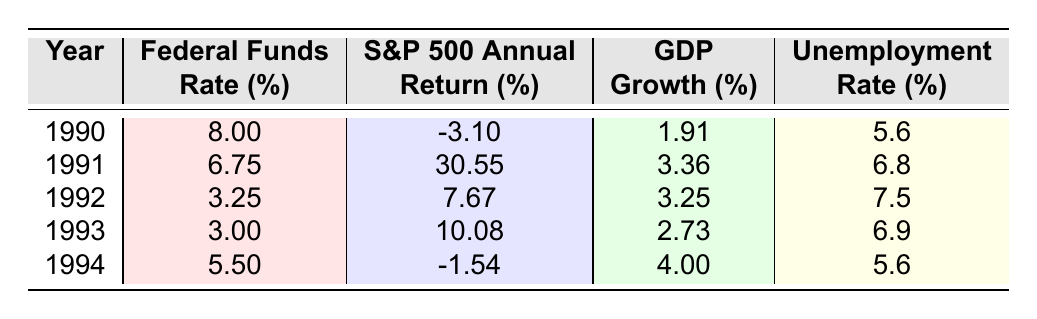What was the Federal Funds Rate in 1992? The table lists the Federal Funds Rate for each year. For 1992, the column shows a rate of 3.25%.
Answer: 3.25% What was the S&P 500 Annual Return in 1990? By checking the S&P 500 Annual Return column for the year 1990, it shows a return of -3.10%.
Answer: -3.10% What is the GDP Growth for 1994? The GDP Growth column indicates that the growth rate for 1994 is 4.00%.
Answer: 4.00% In which year did the S&P 500 Annual Return peak? The S&P 500 Annual Return shows the highest value of 30.55% in 1991.
Answer: 1991 What was the trend in Federal Funds Rates from 1990 to 1994? By comparing the values in the Federal Funds Rate column, it shows a decrease from 8.00% in 1990 to 3.00% in 1993, then an increase to 5.50% in 1994. Thus, it first decreases and then increases.
Answer: Decreases then increases Calculate the average Federal Funds Rate for the years 1990 to 1994. Adding the rates: 8.00 + 6.75 + 3.25 + 3.00 + 5.50 = 26.50. Then, divide by 5 to find the average: 26.50 / 5 = 5.30.
Answer: 5.30 What was the unemployment rate in 1993? The table provides the unemployment rate for each year, which shows an unemployment rate of 6.9% for 1993.
Answer: 6.9% Was the S&P 500 Annual Return positive in 1994? The S&P 500 Annual Return for 1994 is -1.54%, which is negative. Therefore, it is not positive.
Answer: No How did the unemployment rate change from 1991 to 1994? The unemployment rates for these years are 6.8% in 1991 and 5.6% in 1994. The change shows a decrease, as 5.6% is less than 6.8%.
Answer: Decrease What was the correlation between the Federal Funds Rate and the S&P 500 Annual Return from 1990 to 1994? Reviewing the data, as the Federal Funds Rate decreased (from 8.00% in 1990 to 3.00% in 1993), the S&P 500 Annual Return showed a positive trend, increasing in 1991, 1992, and 1993 before dropping in 1994. This indicates an inverse relationship, not definitive correlation, but suggests that lower rates may lead to higher returns.
Answer: Inverse relationship What was the overall trend in GDP Growth from 1990 to 1994? By analyzing the data, GDP Growth went from 1.91% in 1990, peaked at 4.00% in 1994 after fluctuating in between, suggesting an overall increase, especially notable in 1994.
Answer: Overall increase 